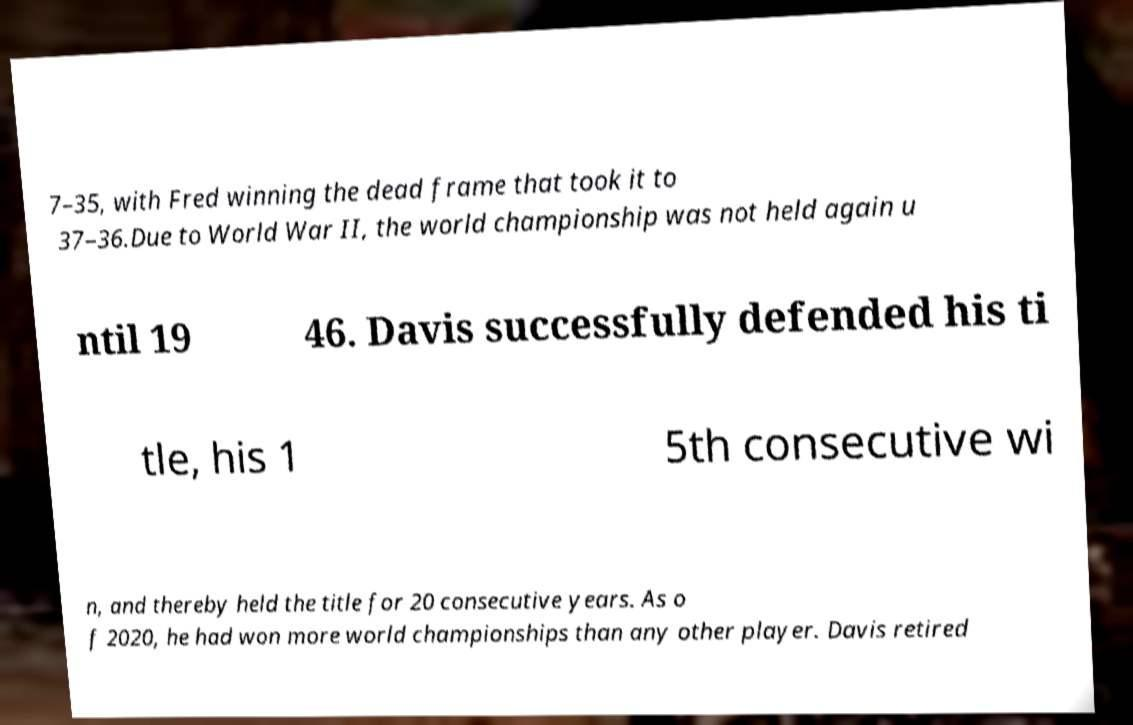Can you accurately transcribe the text from the provided image for me? 7–35, with Fred winning the dead frame that took it to 37–36.Due to World War II, the world championship was not held again u ntil 19 46. Davis successfully defended his ti tle, his 1 5th consecutive wi n, and thereby held the title for 20 consecutive years. As o f 2020, he had won more world championships than any other player. Davis retired 